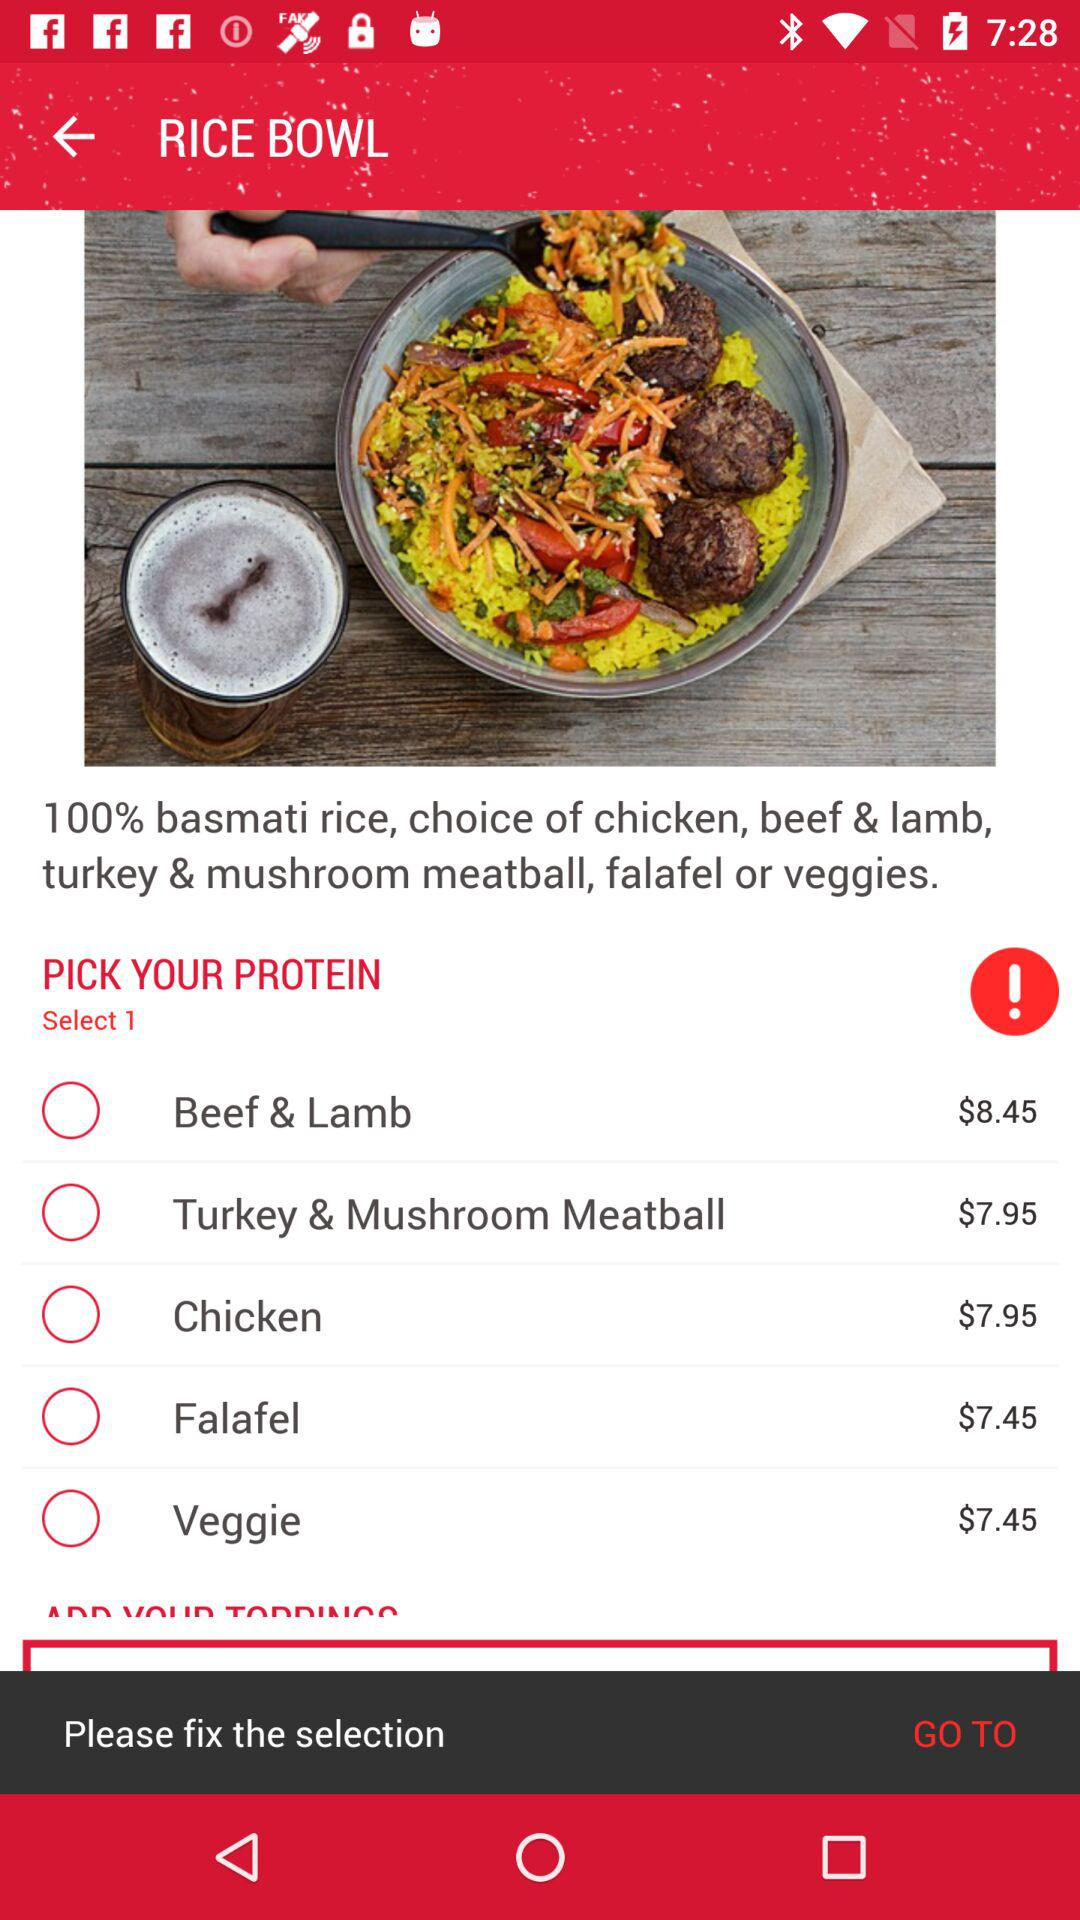What's the cost of chicken? The cost of chicken is $7.95. 